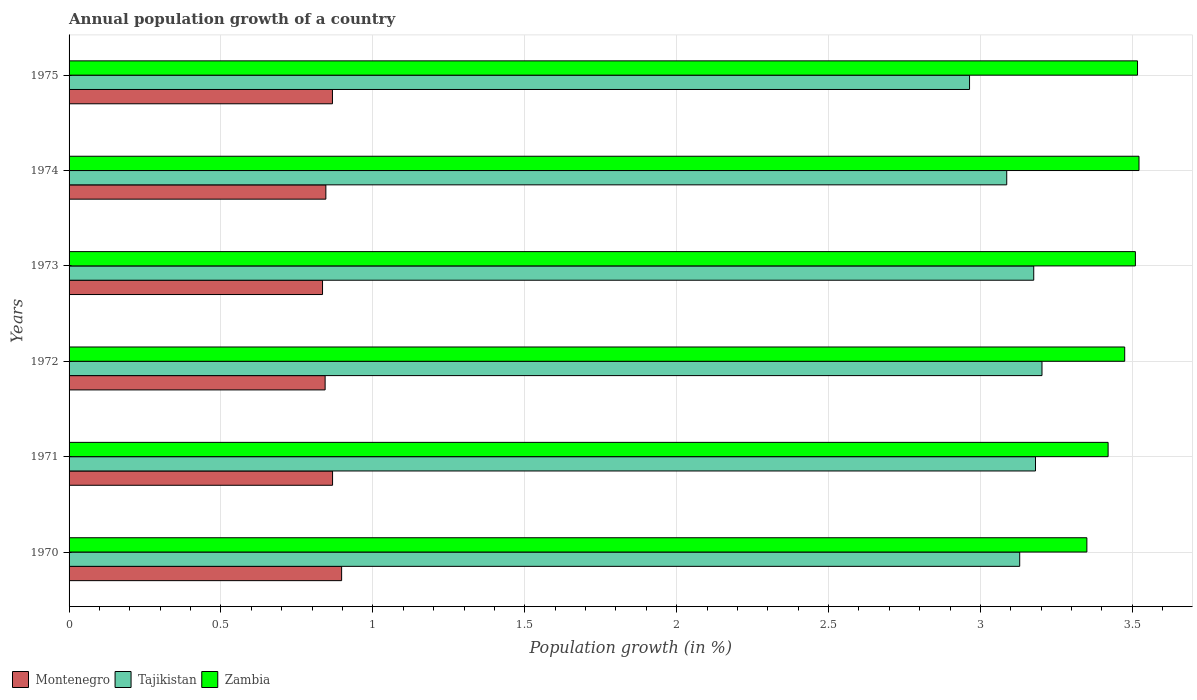How many different coloured bars are there?
Give a very brief answer. 3. How many groups of bars are there?
Your response must be concise. 6. Are the number of bars on each tick of the Y-axis equal?
Your answer should be very brief. Yes. How many bars are there on the 1st tick from the bottom?
Keep it short and to the point. 3. In how many cases, is the number of bars for a given year not equal to the number of legend labels?
Your answer should be compact. 0. What is the annual population growth in Tajikistan in 1975?
Your answer should be very brief. 2.96. Across all years, what is the maximum annual population growth in Zambia?
Your answer should be compact. 3.52. Across all years, what is the minimum annual population growth in Zambia?
Your answer should be very brief. 3.35. What is the total annual population growth in Tajikistan in the graph?
Offer a very short reply. 18.74. What is the difference between the annual population growth in Zambia in 1971 and that in 1975?
Give a very brief answer. -0.1. What is the difference between the annual population growth in Zambia in 1975 and the annual population growth in Tajikistan in 1972?
Your answer should be compact. 0.31. What is the average annual population growth in Zambia per year?
Keep it short and to the point. 3.47. In the year 1974, what is the difference between the annual population growth in Montenegro and annual population growth in Zambia?
Keep it short and to the point. -2.68. What is the ratio of the annual population growth in Zambia in 1971 to that in 1972?
Offer a very short reply. 0.98. Is the annual population growth in Tajikistan in 1971 less than that in 1974?
Your response must be concise. No. What is the difference between the highest and the second highest annual population growth in Zambia?
Ensure brevity in your answer.  0. What is the difference between the highest and the lowest annual population growth in Montenegro?
Your answer should be compact. 0.06. In how many years, is the annual population growth in Zambia greater than the average annual population growth in Zambia taken over all years?
Offer a terse response. 4. What does the 3rd bar from the top in 1975 represents?
Your answer should be compact. Montenegro. What does the 2nd bar from the bottom in 1973 represents?
Provide a short and direct response. Tajikistan. Is it the case that in every year, the sum of the annual population growth in Montenegro and annual population growth in Zambia is greater than the annual population growth in Tajikistan?
Your answer should be compact. Yes. How many bars are there?
Provide a succinct answer. 18. Does the graph contain any zero values?
Ensure brevity in your answer.  No. Where does the legend appear in the graph?
Keep it short and to the point. Bottom left. How many legend labels are there?
Offer a terse response. 3. How are the legend labels stacked?
Your answer should be compact. Horizontal. What is the title of the graph?
Offer a terse response. Annual population growth of a country. What is the label or title of the X-axis?
Offer a very short reply. Population growth (in %). What is the label or title of the Y-axis?
Keep it short and to the point. Years. What is the Population growth (in %) in Montenegro in 1970?
Offer a terse response. 0.9. What is the Population growth (in %) in Tajikistan in 1970?
Your answer should be very brief. 3.13. What is the Population growth (in %) of Zambia in 1970?
Your answer should be compact. 3.35. What is the Population growth (in %) in Montenegro in 1971?
Make the answer very short. 0.87. What is the Population growth (in %) in Tajikistan in 1971?
Provide a short and direct response. 3.18. What is the Population growth (in %) in Zambia in 1971?
Provide a succinct answer. 3.42. What is the Population growth (in %) of Montenegro in 1972?
Your answer should be very brief. 0.84. What is the Population growth (in %) in Tajikistan in 1972?
Provide a succinct answer. 3.2. What is the Population growth (in %) of Zambia in 1972?
Provide a succinct answer. 3.47. What is the Population growth (in %) in Montenegro in 1973?
Your answer should be very brief. 0.83. What is the Population growth (in %) in Tajikistan in 1973?
Provide a short and direct response. 3.18. What is the Population growth (in %) in Zambia in 1973?
Your response must be concise. 3.51. What is the Population growth (in %) in Montenegro in 1974?
Provide a succinct answer. 0.85. What is the Population growth (in %) in Tajikistan in 1974?
Make the answer very short. 3.09. What is the Population growth (in %) in Zambia in 1974?
Provide a short and direct response. 3.52. What is the Population growth (in %) of Montenegro in 1975?
Your response must be concise. 0.87. What is the Population growth (in %) of Tajikistan in 1975?
Your response must be concise. 2.96. What is the Population growth (in %) of Zambia in 1975?
Your answer should be compact. 3.52. Across all years, what is the maximum Population growth (in %) in Montenegro?
Make the answer very short. 0.9. Across all years, what is the maximum Population growth (in %) of Tajikistan?
Your answer should be very brief. 3.2. Across all years, what is the maximum Population growth (in %) in Zambia?
Offer a terse response. 3.52. Across all years, what is the minimum Population growth (in %) of Montenegro?
Give a very brief answer. 0.83. Across all years, what is the minimum Population growth (in %) of Tajikistan?
Keep it short and to the point. 2.96. Across all years, what is the minimum Population growth (in %) of Zambia?
Offer a very short reply. 3.35. What is the total Population growth (in %) in Montenegro in the graph?
Offer a terse response. 5.15. What is the total Population growth (in %) in Tajikistan in the graph?
Your answer should be compact. 18.74. What is the total Population growth (in %) of Zambia in the graph?
Ensure brevity in your answer.  20.79. What is the difference between the Population growth (in %) of Montenegro in 1970 and that in 1971?
Your answer should be compact. 0.03. What is the difference between the Population growth (in %) of Tajikistan in 1970 and that in 1971?
Provide a short and direct response. -0.05. What is the difference between the Population growth (in %) of Zambia in 1970 and that in 1971?
Keep it short and to the point. -0.07. What is the difference between the Population growth (in %) of Montenegro in 1970 and that in 1972?
Offer a very short reply. 0.05. What is the difference between the Population growth (in %) of Tajikistan in 1970 and that in 1972?
Your response must be concise. -0.07. What is the difference between the Population growth (in %) of Zambia in 1970 and that in 1972?
Make the answer very short. -0.12. What is the difference between the Population growth (in %) of Montenegro in 1970 and that in 1973?
Your answer should be very brief. 0.06. What is the difference between the Population growth (in %) of Tajikistan in 1970 and that in 1973?
Ensure brevity in your answer.  -0.05. What is the difference between the Population growth (in %) in Zambia in 1970 and that in 1973?
Give a very brief answer. -0.16. What is the difference between the Population growth (in %) of Montenegro in 1970 and that in 1974?
Ensure brevity in your answer.  0.05. What is the difference between the Population growth (in %) in Tajikistan in 1970 and that in 1974?
Your answer should be compact. 0.04. What is the difference between the Population growth (in %) in Zambia in 1970 and that in 1974?
Provide a short and direct response. -0.17. What is the difference between the Population growth (in %) of Montenegro in 1970 and that in 1975?
Make the answer very short. 0.03. What is the difference between the Population growth (in %) in Tajikistan in 1970 and that in 1975?
Offer a very short reply. 0.17. What is the difference between the Population growth (in %) of Montenegro in 1971 and that in 1972?
Your answer should be very brief. 0.02. What is the difference between the Population growth (in %) of Tajikistan in 1971 and that in 1972?
Your answer should be very brief. -0.02. What is the difference between the Population growth (in %) in Zambia in 1971 and that in 1972?
Your answer should be compact. -0.05. What is the difference between the Population growth (in %) of Montenegro in 1971 and that in 1973?
Your answer should be compact. 0.03. What is the difference between the Population growth (in %) in Tajikistan in 1971 and that in 1973?
Offer a very short reply. 0.01. What is the difference between the Population growth (in %) of Zambia in 1971 and that in 1973?
Make the answer very short. -0.09. What is the difference between the Population growth (in %) of Montenegro in 1971 and that in 1974?
Your answer should be compact. 0.02. What is the difference between the Population growth (in %) of Tajikistan in 1971 and that in 1974?
Keep it short and to the point. 0.09. What is the difference between the Population growth (in %) in Zambia in 1971 and that in 1974?
Keep it short and to the point. -0.1. What is the difference between the Population growth (in %) in Tajikistan in 1971 and that in 1975?
Your answer should be compact. 0.22. What is the difference between the Population growth (in %) in Zambia in 1971 and that in 1975?
Provide a short and direct response. -0.1. What is the difference between the Population growth (in %) in Montenegro in 1972 and that in 1973?
Your answer should be compact. 0.01. What is the difference between the Population growth (in %) of Tajikistan in 1972 and that in 1973?
Your answer should be very brief. 0.03. What is the difference between the Population growth (in %) in Zambia in 1972 and that in 1973?
Keep it short and to the point. -0.04. What is the difference between the Population growth (in %) in Montenegro in 1972 and that in 1974?
Provide a succinct answer. -0. What is the difference between the Population growth (in %) of Tajikistan in 1972 and that in 1974?
Offer a terse response. 0.12. What is the difference between the Population growth (in %) in Zambia in 1972 and that in 1974?
Make the answer very short. -0.05. What is the difference between the Population growth (in %) in Montenegro in 1972 and that in 1975?
Your response must be concise. -0.02. What is the difference between the Population growth (in %) of Tajikistan in 1972 and that in 1975?
Give a very brief answer. 0.24. What is the difference between the Population growth (in %) of Zambia in 1972 and that in 1975?
Give a very brief answer. -0.04. What is the difference between the Population growth (in %) of Montenegro in 1973 and that in 1974?
Your answer should be very brief. -0.01. What is the difference between the Population growth (in %) of Tajikistan in 1973 and that in 1974?
Keep it short and to the point. 0.09. What is the difference between the Population growth (in %) of Zambia in 1973 and that in 1974?
Your response must be concise. -0.01. What is the difference between the Population growth (in %) of Montenegro in 1973 and that in 1975?
Offer a terse response. -0.03. What is the difference between the Population growth (in %) of Tajikistan in 1973 and that in 1975?
Your answer should be very brief. 0.21. What is the difference between the Population growth (in %) in Zambia in 1973 and that in 1975?
Keep it short and to the point. -0.01. What is the difference between the Population growth (in %) of Montenegro in 1974 and that in 1975?
Give a very brief answer. -0.02. What is the difference between the Population growth (in %) of Tajikistan in 1974 and that in 1975?
Provide a succinct answer. 0.12. What is the difference between the Population growth (in %) of Zambia in 1974 and that in 1975?
Offer a very short reply. 0. What is the difference between the Population growth (in %) in Montenegro in 1970 and the Population growth (in %) in Tajikistan in 1971?
Keep it short and to the point. -2.28. What is the difference between the Population growth (in %) of Montenegro in 1970 and the Population growth (in %) of Zambia in 1971?
Your answer should be very brief. -2.52. What is the difference between the Population growth (in %) in Tajikistan in 1970 and the Population growth (in %) in Zambia in 1971?
Your answer should be very brief. -0.29. What is the difference between the Population growth (in %) in Montenegro in 1970 and the Population growth (in %) in Tajikistan in 1972?
Provide a short and direct response. -2.31. What is the difference between the Population growth (in %) of Montenegro in 1970 and the Population growth (in %) of Zambia in 1972?
Give a very brief answer. -2.58. What is the difference between the Population growth (in %) in Tajikistan in 1970 and the Population growth (in %) in Zambia in 1972?
Ensure brevity in your answer.  -0.35. What is the difference between the Population growth (in %) in Montenegro in 1970 and the Population growth (in %) in Tajikistan in 1973?
Keep it short and to the point. -2.28. What is the difference between the Population growth (in %) in Montenegro in 1970 and the Population growth (in %) in Zambia in 1973?
Keep it short and to the point. -2.61. What is the difference between the Population growth (in %) of Tajikistan in 1970 and the Population growth (in %) of Zambia in 1973?
Give a very brief answer. -0.38. What is the difference between the Population growth (in %) of Montenegro in 1970 and the Population growth (in %) of Tajikistan in 1974?
Your answer should be very brief. -2.19. What is the difference between the Population growth (in %) in Montenegro in 1970 and the Population growth (in %) in Zambia in 1974?
Offer a very short reply. -2.62. What is the difference between the Population growth (in %) in Tajikistan in 1970 and the Population growth (in %) in Zambia in 1974?
Give a very brief answer. -0.39. What is the difference between the Population growth (in %) of Montenegro in 1970 and the Population growth (in %) of Tajikistan in 1975?
Your answer should be very brief. -2.07. What is the difference between the Population growth (in %) of Montenegro in 1970 and the Population growth (in %) of Zambia in 1975?
Give a very brief answer. -2.62. What is the difference between the Population growth (in %) of Tajikistan in 1970 and the Population growth (in %) of Zambia in 1975?
Provide a short and direct response. -0.39. What is the difference between the Population growth (in %) of Montenegro in 1971 and the Population growth (in %) of Tajikistan in 1972?
Keep it short and to the point. -2.34. What is the difference between the Population growth (in %) in Montenegro in 1971 and the Population growth (in %) in Zambia in 1972?
Give a very brief answer. -2.61. What is the difference between the Population growth (in %) in Tajikistan in 1971 and the Population growth (in %) in Zambia in 1972?
Offer a very short reply. -0.29. What is the difference between the Population growth (in %) in Montenegro in 1971 and the Population growth (in %) in Tajikistan in 1973?
Provide a succinct answer. -2.31. What is the difference between the Population growth (in %) in Montenegro in 1971 and the Population growth (in %) in Zambia in 1973?
Offer a very short reply. -2.64. What is the difference between the Population growth (in %) in Tajikistan in 1971 and the Population growth (in %) in Zambia in 1973?
Keep it short and to the point. -0.33. What is the difference between the Population growth (in %) of Montenegro in 1971 and the Population growth (in %) of Tajikistan in 1974?
Make the answer very short. -2.22. What is the difference between the Population growth (in %) of Montenegro in 1971 and the Population growth (in %) of Zambia in 1974?
Offer a very short reply. -2.65. What is the difference between the Population growth (in %) in Tajikistan in 1971 and the Population growth (in %) in Zambia in 1974?
Offer a very short reply. -0.34. What is the difference between the Population growth (in %) of Montenegro in 1971 and the Population growth (in %) of Tajikistan in 1975?
Make the answer very short. -2.1. What is the difference between the Population growth (in %) of Montenegro in 1971 and the Population growth (in %) of Zambia in 1975?
Your response must be concise. -2.65. What is the difference between the Population growth (in %) of Tajikistan in 1971 and the Population growth (in %) of Zambia in 1975?
Make the answer very short. -0.34. What is the difference between the Population growth (in %) in Montenegro in 1972 and the Population growth (in %) in Tajikistan in 1973?
Ensure brevity in your answer.  -2.33. What is the difference between the Population growth (in %) in Montenegro in 1972 and the Population growth (in %) in Zambia in 1973?
Your response must be concise. -2.67. What is the difference between the Population growth (in %) of Tajikistan in 1972 and the Population growth (in %) of Zambia in 1973?
Your answer should be very brief. -0.31. What is the difference between the Population growth (in %) of Montenegro in 1972 and the Population growth (in %) of Tajikistan in 1974?
Make the answer very short. -2.24. What is the difference between the Population growth (in %) in Montenegro in 1972 and the Population growth (in %) in Zambia in 1974?
Offer a terse response. -2.68. What is the difference between the Population growth (in %) of Tajikistan in 1972 and the Population growth (in %) of Zambia in 1974?
Ensure brevity in your answer.  -0.32. What is the difference between the Population growth (in %) in Montenegro in 1972 and the Population growth (in %) in Tajikistan in 1975?
Keep it short and to the point. -2.12. What is the difference between the Population growth (in %) in Montenegro in 1972 and the Population growth (in %) in Zambia in 1975?
Ensure brevity in your answer.  -2.67. What is the difference between the Population growth (in %) in Tajikistan in 1972 and the Population growth (in %) in Zambia in 1975?
Provide a succinct answer. -0.31. What is the difference between the Population growth (in %) of Montenegro in 1973 and the Population growth (in %) of Tajikistan in 1974?
Your answer should be very brief. -2.25. What is the difference between the Population growth (in %) of Montenegro in 1973 and the Population growth (in %) of Zambia in 1974?
Offer a terse response. -2.69. What is the difference between the Population growth (in %) in Tajikistan in 1973 and the Population growth (in %) in Zambia in 1974?
Your answer should be compact. -0.35. What is the difference between the Population growth (in %) of Montenegro in 1973 and the Population growth (in %) of Tajikistan in 1975?
Provide a short and direct response. -2.13. What is the difference between the Population growth (in %) of Montenegro in 1973 and the Population growth (in %) of Zambia in 1975?
Provide a short and direct response. -2.68. What is the difference between the Population growth (in %) of Tajikistan in 1973 and the Population growth (in %) of Zambia in 1975?
Offer a terse response. -0.34. What is the difference between the Population growth (in %) of Montenegro in 1974 and the Population growth (in %) of Tajikistan in 1975?
Provide a succinct answer. -2.12. What is the difference between the Population growth (in %) in Montenegro in 1974 and the Population growth (in %) in Zambia in 1975?
Provide a succinct answer. -2.67. What is the difference between the Population growth (in %) of Tajikistan in 1974 and the Population growth (in %) of Zambia in 1975?
Provide a short and direct response. -0.43. What is the average Population growth (in %) in Montenegro per year?
Make the answer very short. 0.86. What is the average Population growth (in %) in Tajikistan per year?
Your response must be concise. 3.12. What is the average Population growth (in %) in Zambia per year?
Give a very brief answer. 3.47. In the year 1970, what is the difference between the Population growth (in %) of Montenegro and Population growth (in %) of Tajikistan?
Give a very brief answer. -2.23. In the year 1970, what is the difference between the Population growth (in %) in Montenegro and Population growth (in %) in Zambia?
Offer a very short reply. -2.45. In the year 1970, what is the difference between the Population growth (in %) in Tajikistan and Population growth (in %) in Zambia?
Your answer should be compact. -0.22. In the year 1971, what is the difference between the Population growth (in %) of Montenegro and Population growth (in %) of Tajikistan?
Your response must be concise. -2.31. In the year 1971, what is the difference between the Population growth (in %) in Montenegro and Population growth (in %) in Zambia?
Offer a terse response. -2.55. In the year 1971, what is the difference between the Population growth (in %) of Tajikistan and Population growth (in %) of Zambia?
Give a very brief answer. -0.24. In the year 1972, what is the difference between the Population growth (in %) of Montenegro and Population growth (in %) of Tajikistan?
Offer a very short reply. -2.36. In the year 1972, what is the difference between the Population growth (in %) in Montenegro and Population growth (in %) in Zambia?
Make the answer very short. -2.63. In the year 1972, what is the difference between the Population growth (in %) of Tajikistan and Population growth (in %) of Zambia?
Your answer should be very brief. -0.27. In the year 1973, what is the difference between the Population growth (in %) of Montenegro and Population growth (in %) of Tajikistan?
Provide a short and direct response. -2.34. In the year 1973, what is the difference between the Population growth (in %) of Montenegro and Population growth (in %) of Zambia?
Your response must be concise. -2.68. In the year 1973, what is the difference between the Population growth (in %) of Tajikistan and Population growth (in %) of Zambia?
Offer a very short reply. -0.33. In the year 1974, what is the difference between the Population growth (in %) of Montenegro and Population growth (in %) of Tajikistan?
Offer a terse response. -2.24. In the year 1974, what is the difference between the Population growth (in %) of Montenegro and Population growth (in %) of Zambia?
Provide a succinct answer. -2.68. In the year 1974, what is the difference between the Population growth (in %) of Tajikistan and Population growth (in %) of Zambia?
Provide a short and direct response. -0.44. In the year 1975, what is the difference between the Population growth (in %) of Montenegro and Population growth (in %) of Tajikistan?
Give a very brief answer. -2.1. In the year 1975, what is the difference between the Population growth (in %) of Montenegro and Population growth (in %) of Zambia?
Provide a short and direct response. -2.65. In the year 1975, what is the difference between the Population growth (in %) of Tajikistan and Population growth (in %) of Zambia?
Keep it short and to the point. -0.55. What is the ratio of the Population growth (in %) in Montenegro in 1970 to that in 1971?
Offer a terse response. 1.03. What is the ratio of the Population growth (in %) of Tajikistan in 1970 to that in 1971?
Make the answer very short. 0.98. What is the ratio of the Population growth (in %) of Zambia in 1970 to that in 1971?
Keep it short and to the point. 0.98. What is the ratio of the Population growth (in %) of Montenegro in 1970 to that in 1972?
Your answer should be compact. 1.06. What is the ratio of the Population growth (in %) in Tajikistan in 1970 to that in 1972?
Give a very brief answer. 0.98. What is the ratio of the Population growth (in %) in Zambia in 1970 to that in 1972?
Provide a short and direct response. 0.96. What is the ratio of the Population growth (in %) in Montenegro in 1970 to that in 1973?
Your answer should be very brief. 1.08. What is the ratio of the Population growth (in %) of Tajikistan in 1970 to that in 1973?
Offer a terse response. 0.99. What is the ratio of the Population growth (in %) in Zambia in 1970 to that in 1973?
Offer a very short reply. 0.95. What is the ratio of the Population growth (in %) in Montenegro in 1970 to that in 1974?
Ensure brevity in your answer.  1.06. What is the ratio of the Population growth (in %) in Tajikistan in 1970 to that in 1974?
Ensure brevity in your answer.  1.01. What is the ratio of the Population growth (in %) in Zambia in 1970 to that in 1974?
Your answer should be compact. 0.95. What is the ratio of the Population growth (in %) of Montenegro in 1970 to that in 1975?
Provide a short and direct response. 1.03. What is the ratio of the Population growth (in %) in Tajikistan in 1970 to that in 1975?
Provide a succinct answer. 1.06. What is the ratio of the Population growth (in %) in Zambia in 1970 to that in 1975?
Offer a very short reply. 0.95. What is the ratio of the Population growth (in %) in Tajikistan in 1971 to that in 1972?
Provide a succinct answer. 0.99. What is the ratio of the Population growth (in %) of Zambia in 1971 to that in 1972?
Your answer should be very brief. 0.98. What is the ratio of the Population growth (in %) of Montenegro in 1971 to that in 1973?
Offer a terse response. 1.04. What is the ratio of the Population growth (in %) of Zambia in 1971 to that in 1973?
Offer a terse response. 0.97. What is the ratio of the Population growth (in %) in Montenegro in 1971 to that in 1974?
Provide a succinct answer. 1.03. What is the ratio of the Population growth (in %) in Tajikistan in 1971 to that in 1974?
Ensure brevity in your answer.  1.03. What is the ratio of the Population growth (in %) in Zambia in 1971 to that in 1974?
Your answer should be very brief. 0.97. What is the ratio of the Population growth (in %) in Tajikistan in 1971 to that in 1975?
Give a very brief answer. 1.07. What is the ratio of the Population growth (in %) in Zambia in 1971 to that in 1975?
Provide a short and direct response. 0.97. What is the ratio of the Population growth (in %) in Montenegro in 1972 to that in 1973?
Your answer should be compact. 1.01. What is the ratio of the Population growth (in %) in Tajikistan in 1972 to that in 1973?
Provide a succinct answer. 1.01. What is the ratio of the Population growth (in %) in Zambia in 1972 to that in 1973?
Your answer should be very brief. 0.99. What is the ratio of the Population growth (in %) in Tajikistan in 1972 to that in 1974?
Ensure brevity in your answer.  1.04. What is the ratio of the Population growth (in %) in Zambia in 1972 to that in 1974?
Make the answer very short. 0.99. What is the ratio of the Population growth (in %) in Montenegro in 1972 to that in 1975?
Your answer should be very brief. 0.97. What is the ratio of the Population growth (in %) in Tajikistan in 1972 to that in 1975?
Keep it short and to the point. 1.08. What is the ratio of the Population growth (in %) of Montenegro in 1973 to that in 1974?
Offer a terse response. 0.99. What is the ratio of the Population growth (in %) of Tajikistan in 1973 to that in 1974?
Your answer should be compact. 1.03. What is the ratio of the Population growth (in %) in Montenegro in 1973 to that in 1975?
Ensure brevity in your answer.  0.96. What is the ratio of the Population growth (in %) of Tajikistan in 1973 to that in 1975?
Offer a very short reply. 1.07. What is the ratio of the Population growth (in %) of Tajikistan in 1974 to that in 1975?
Ensure brevity in your answer.  1.04. What is the difference between the highest and the second highest Population growth (in %) of Montenegro?
Give a very brief answer. 0.03. What is the difference between the highest and the second highest Population growth (in %) of Tajikistan?
Keep it short and to the point. 0.02. What is the difference between the highest and the second highest Population growth (in %) in Zambia?
Make the answer very short. 0. What is the difference between the highest and the lowest Population growth (in %) in Montenegro?
Keep it short and to the point. 0.06. What is the difference between the highest and the lowest Population growth (in %) in Tajikistan?
Your response must be concise. 0.24. What is the difference between the highest and the lowest Population growth (in %) in Zambia?
Your response must be concise. 0.17. 